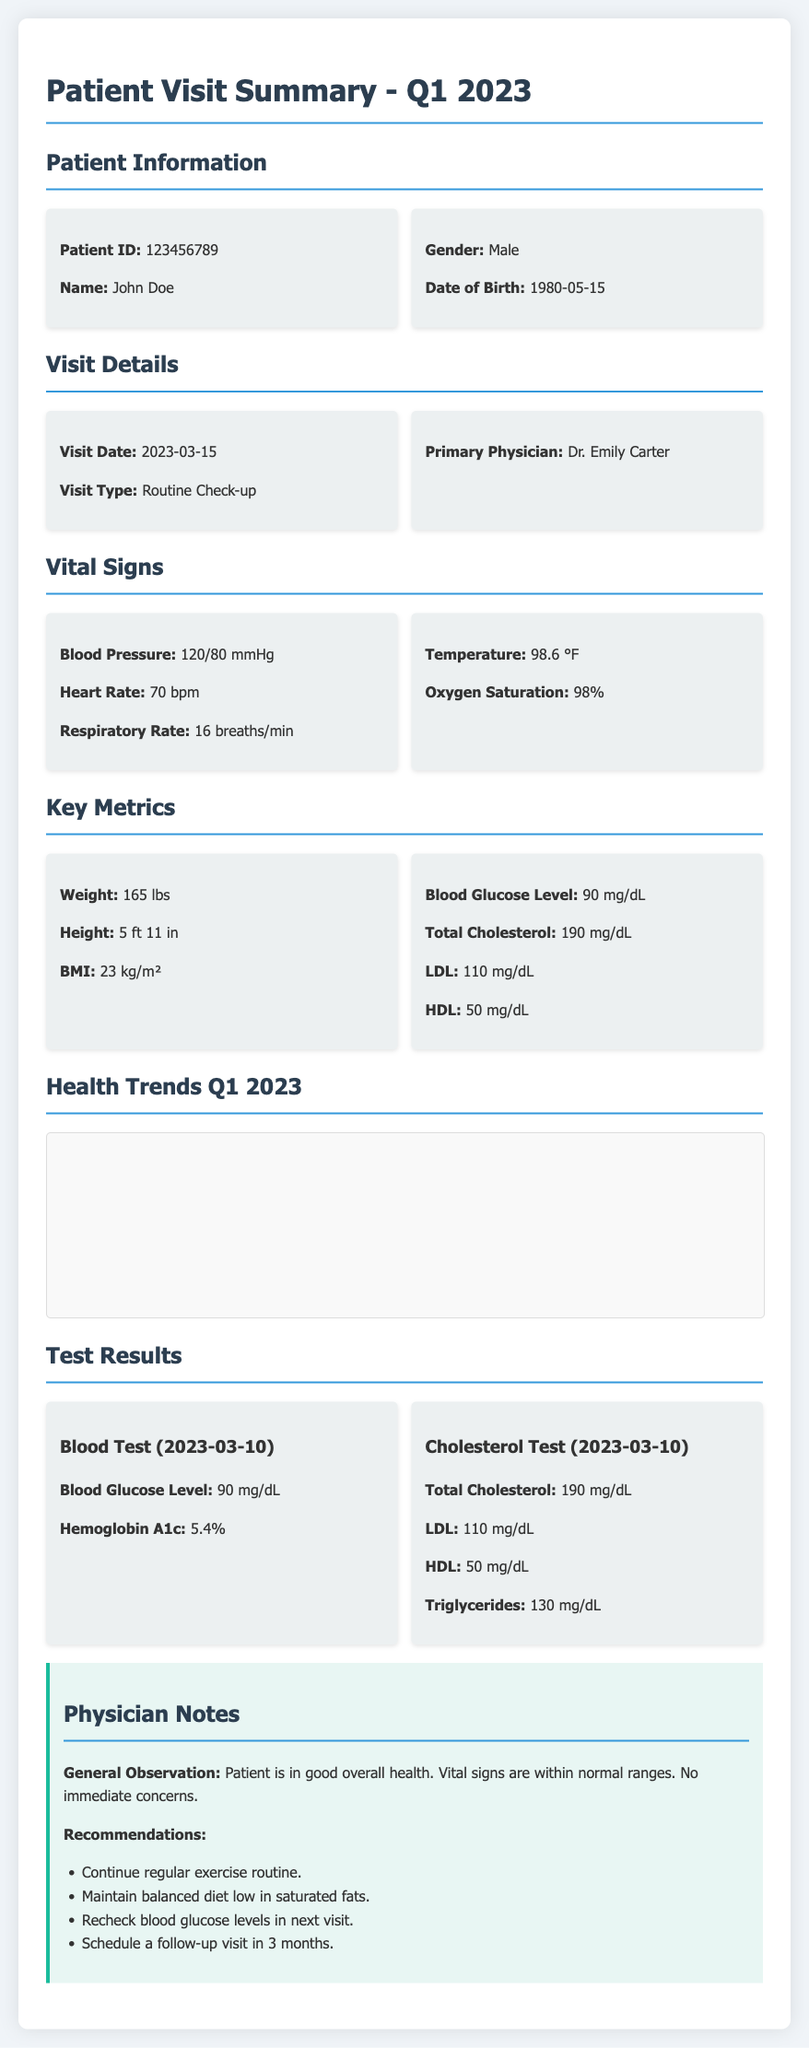what is the patient's name? The patient's name is stated at the beginning of the document under Patient Information.
Answer: John Doe what is the visit date? The visit date is mentioned in the Visit Details section of the document.
Answer: 2023-03-15 who is the primary physician? The primary physician's name is provided in the Visit Details section.
Answer: Dr. Emily Carter what is the blood pressure reading? The blood pressure is listed in the Vital Signs section of the document.
Answer: 120/80 mmHg what are the recommendations from the physician? The recommendations are outlined in the Physician Notes section.
Answer: Continue regular exercise routine how many tests were conducted on March 10, 2023? The number of tests is determined by counting the test results in the Test Results section for that date.
Answer: 2 what was the LDL level recorded? The LDL level is found in the Key Metrics section.
Answer: 110 mg/dL what is the blood glucose level from the blood test? The blood glucose level is indicated in the Blood Test results section for the date it was conducted.
Answer: 90 mg/dL how tall is the patient? The patient's height is specified in the Key Metrics section of the document.
Answer: 5 ft 11 in 